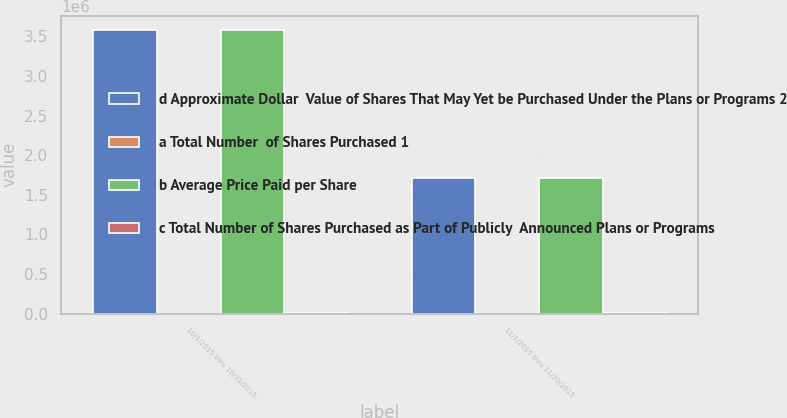<chart> <loc_0><loc_0><loc_500><loc_500><stacked_bar_chart><ecel><fcel>10/1/2015 thru 10/31/2015<fcel>11/1/2015 thru 11/30/2015<nl><fcel>d Approximate Dollar  Value of Shares That May Yet be Purchased Under the Plans or Programs 2<fcel>3.582e+06<fcel>1.71841e+06<nl><fcel>a Total Number  of Shares Purchased 1<fcel>139.77<fcel>145.83<nl><fcel>b Average Price Paid per Share<fcel>3.57776e+06<fcel>1.7146e+06<nl><fcel>c Total Number of Shares Purchased as Part of Publicly  Announced Plans or Programs<fcel>5500<fcel>5250<nl></chart> 